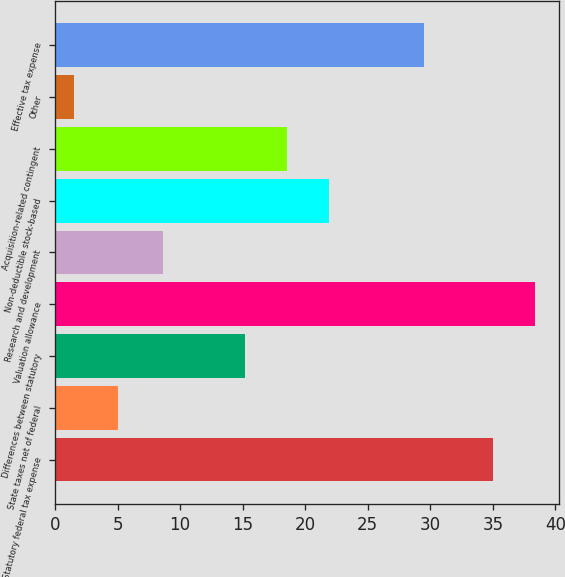<chart> <loc_0><loc_0><loc_500><loc_500><bar_chart><fcel>Statutory federal tax expense<fcel>State taxes net of federal<fcel>Differences between statutory<fcel>Valuation allowance<fcel>Research and development<fcel>Non-deductible stock-based<fcel>Acquisition-related contingent<fcel>Other<fcel>Effective tax expense<nl><fcel>35<fcel>5<fcel>15.2<fcel>38.35<fcel>8.6<fcel>21.9<fcel>18.55<fcel>1.5<fcel>29.5<nl></chart> 